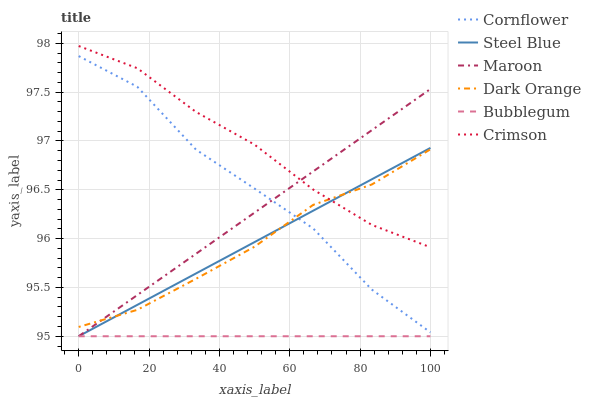Does Dark Orange have the minimum area under the curve?
Answer yes or no. No. Does Dark Orange have the maximum area under the curve?
Answer yes or no. No. Is Dark Orange the smoothest?
Answer yes or no. No. Is Dark Orange the roughest?
Answer yes or no. No. Does Dark Orange have the lowest value?
Answer yes or no. No. Does Dark Orange have the highest value?
Answer yes or no. No. Is Cornflower less than Crimson?
Answer yes or no. Yes. Is Cornflower greater than Bubblegum?
Answer yes or no. Yes. Does Cornflower intersect Crimson?
Answer yes or no. No. 